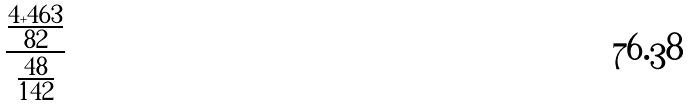Convert formula to latex. <formula><loc_0><loc_0><loc_500><loc_500>\frac { \frac { 4 + 4 6 3 } { 8 2 } } { \frac { 4 8 } { 1 4 2 } }</formula> 